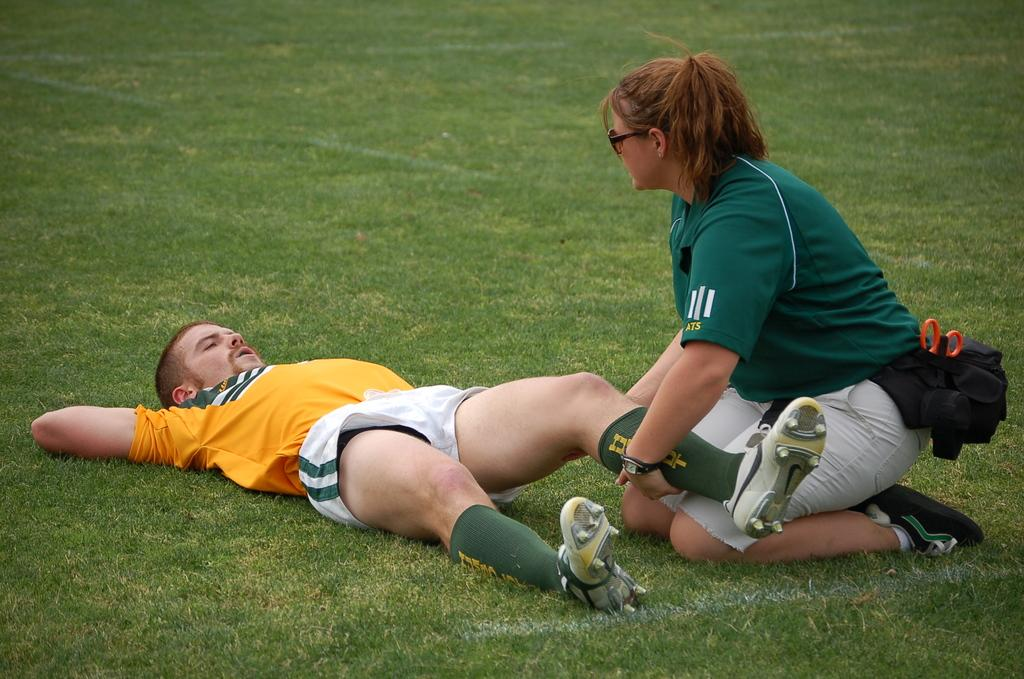How many people are in the image? There are two persons in the image. What is the position of the first person in the image? One person is lying on the ground. What is the position of the second person in the image? The other person is sitting. What is the second person doing while sitting? The sitting person is holding another person. What is the name of the nation that is playing basketball in the image? There is no nation or basketball game present in the image. 